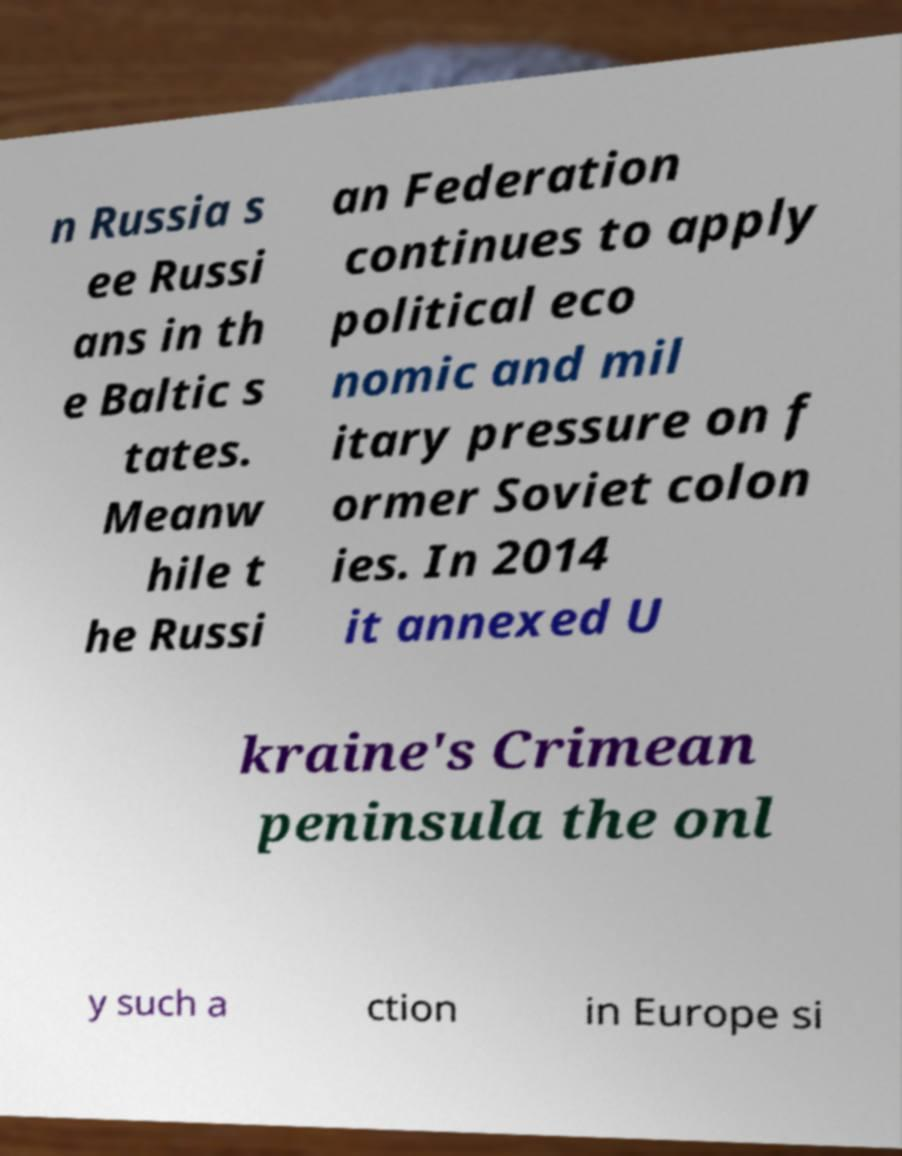Can you read and provide the text displayed in the image?This photo seems to have some interesting text. Can you extract and type it out for me? n Russia s ee Russi ans in th e Baltic s tates. Meanw hile t he Russi an Federation continues to apply political eco nomic and mil itary pressure on f ormer Soviet colon ies. In 2014 it annexed U kraine's Crimean peninsula the onl y such a ction in Europe si 